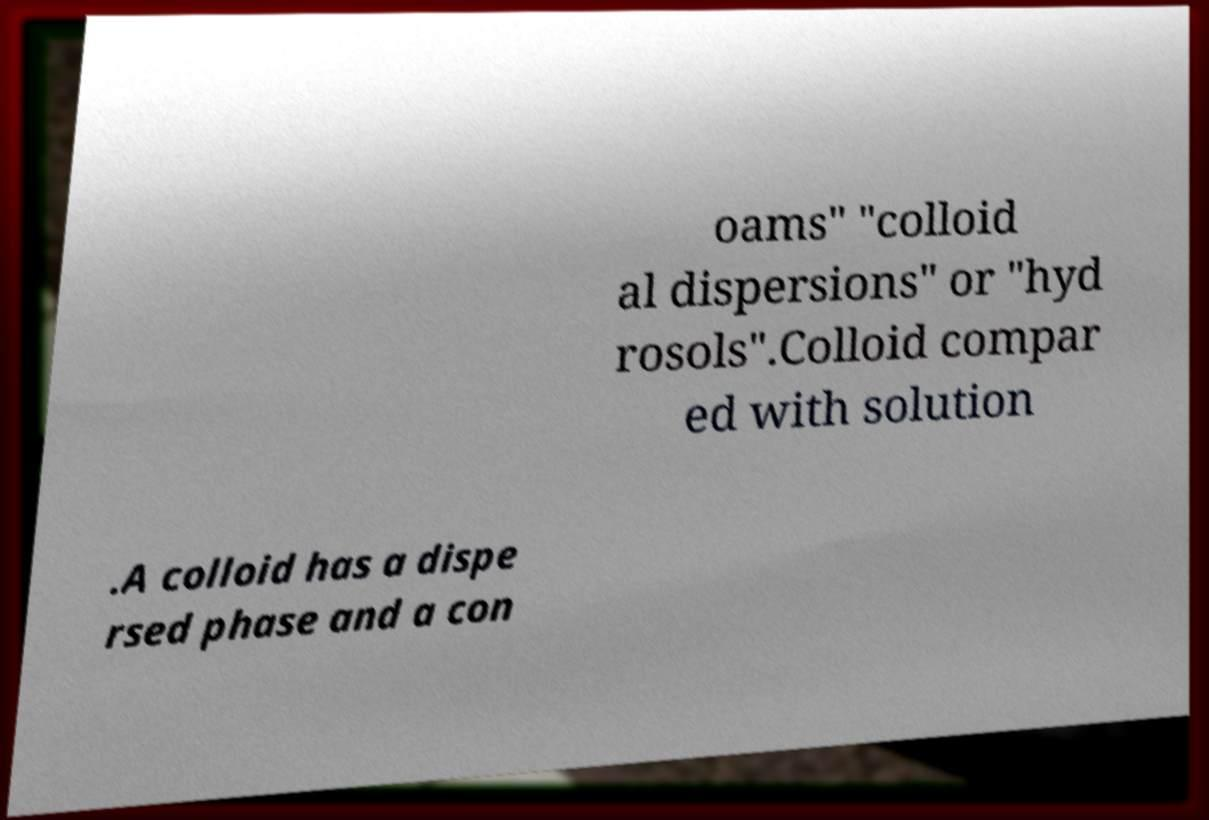Can you accurately transcribe the text from the provided image for me? oams" "colloid al dispersions" or "hyd rosols".Colloid compar ed with solution .A colloid has a dispe rsed phase and a con 